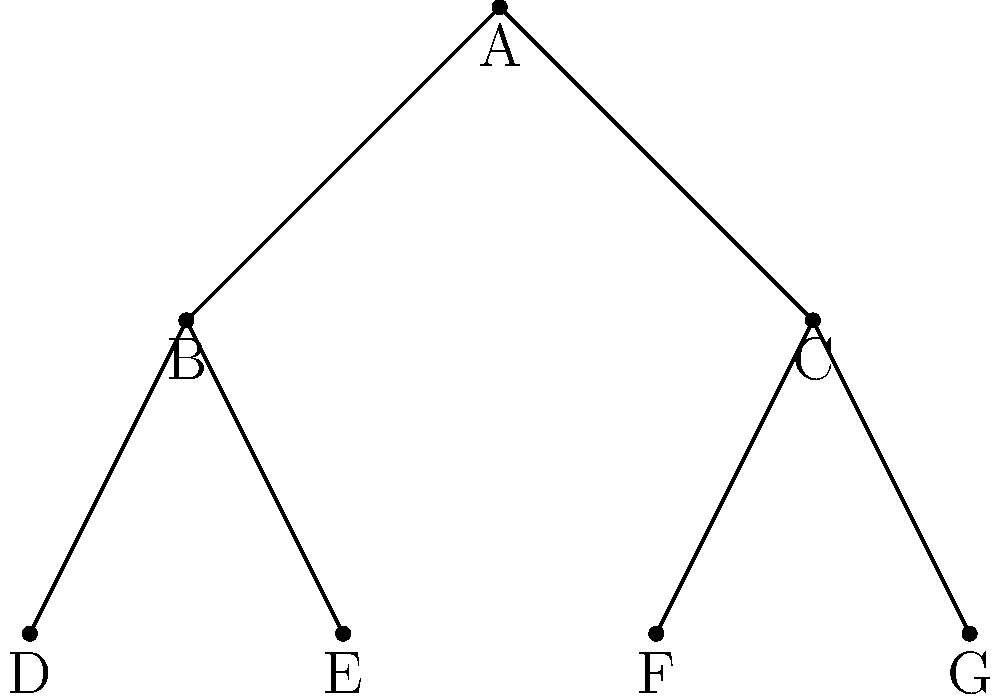Given the coordinate-based representation of a binary tree structure commonly used in functional programming, what is the pre-order traversal of this tree? To determine the pre-order traversal of the given binary tree, we follow these steps:

1. Start at the root node (A).
2. Visit the root node.
3. Recursively traverse the left subtree.
4. Recursively traverse the right subtree.

Following this algorithm:

1. We start at node A and add it to our traversal: A
2. We move to the left child of A, which is B:
   - Visit B: A, B
   - Visit B's left child D: A, B, D
   - D has no children, so we backtrack to B
   - Visit B's right child E: A, B, D, E
   - E has no children, so we backtrack to B, then to A
3. We move to the right child of A, which is C:
   - Visit C: A, B, D, E, C
   - Visit C's left child F: A, B, D, E, C, F
   - F has no children, so we backtrack to C
   - Visit C's right child G: A, B, D, E, C, F, G

Therefore, the pre-order traversal of this tree is A, B, D, E, C, F, G.
Answer: A, B, D, E, C, F, G 